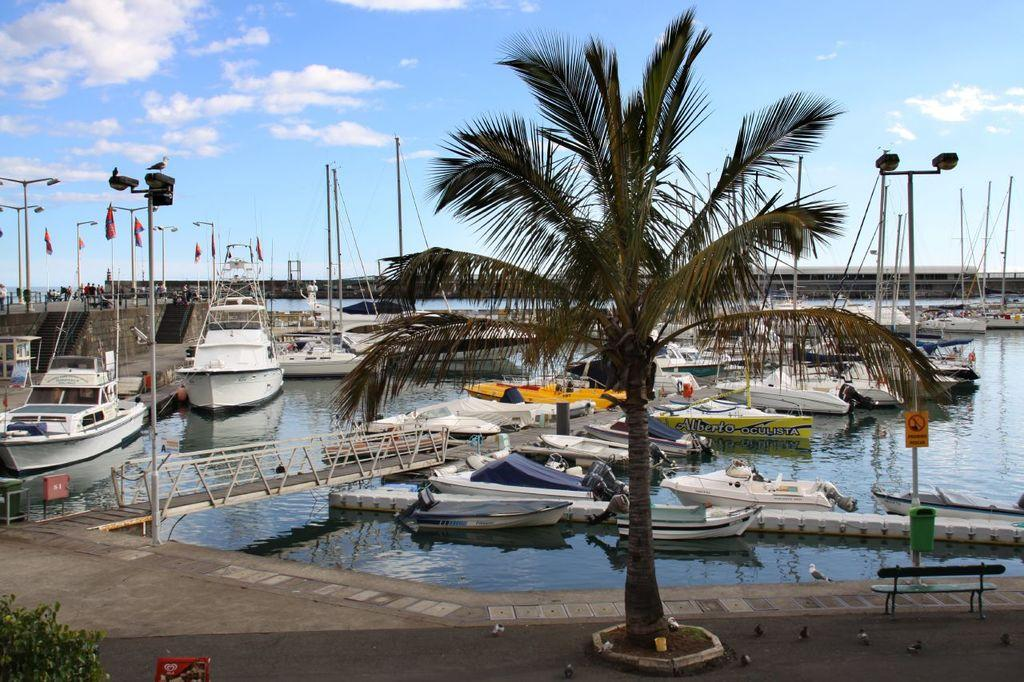What can be seen on the water in the image? There are boats on the water in the image. What type of vegetation is present in the image? There is a tree and plants visible in the image. What structures can be seen in the image? There are poles, a sign board, a bench, and buildings visible in the image. What is visible in the background of the image? There are clouds and buildings visible in the background of the image. What is the limit of the growth of the school in the image? There is no school present in the image, so it is not possible to determine the limit of its growth. 